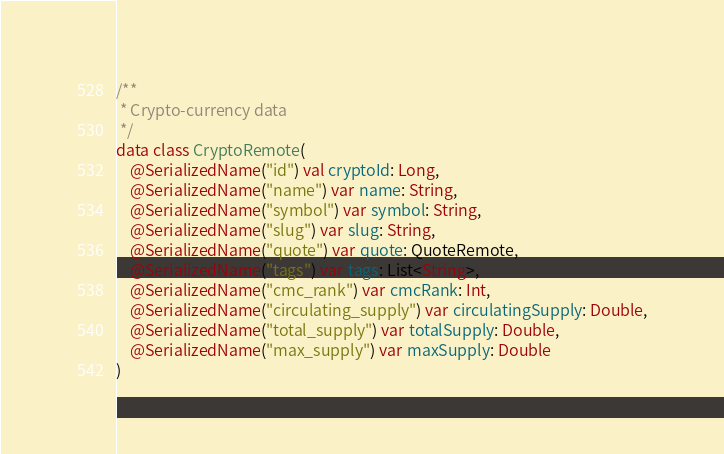<code> <loc_0><loc_0><loc_500><loc_500><_Kotlin_>/**
 * Crypto-currency data
 */
data class CryptoRemote(
    @SerializedName("id") val cryptoId: Long,
    @SerializedName("name") var name: String,
    @SerializedName("symbol") var symbol: String,
    @SerializedName("slug") var slug: String,
    @SerializedName("quote") var quote: QuoteRemote,
    @SerializedName("tags") var tags: List<String>,
    @SerializedName("cmc_rank") var cmcRank: Int,
    @SerializedName("circulating_supply") var circulatingSupply: Double,
    @SerializedName("total_supply") var totalSupply: Double,
    @SerializedName("max_supply") var maxSupply: Double
)</code> 